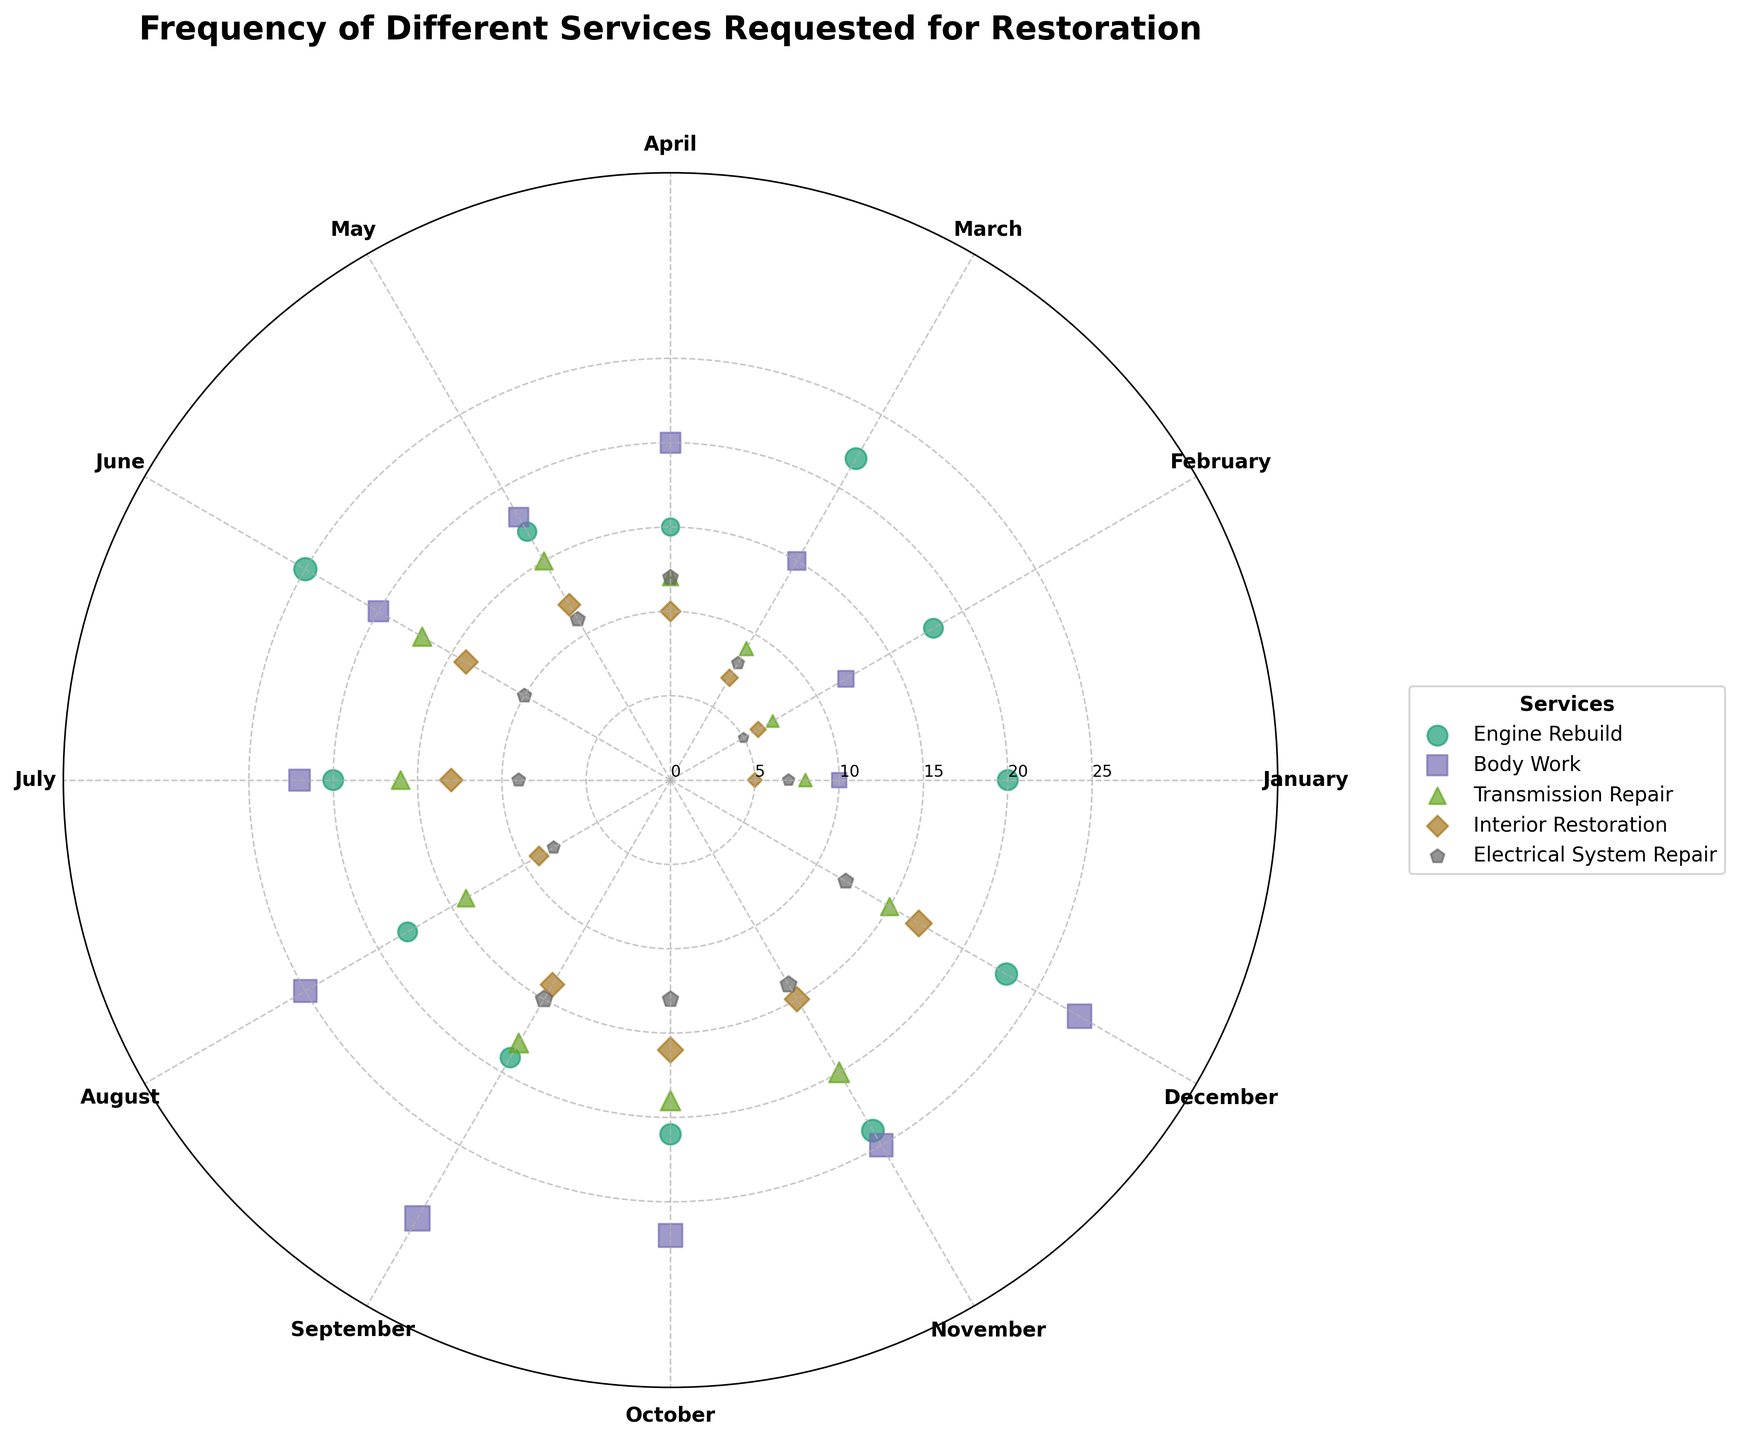What is the title of the chart? The title of the chart appears at the top and reads "Frequency of Different Services Requested for Restoration"
Answer: Frequency of Different Services Requested for Restoration Which service has the highest number of requests in September? A visual inspection of the data points corresponding to September shows that Body Work has the highest number of requests, as indicated by the largest marker in that month
Answer: Body Work How many requests for Engine Rebuild were made in June? Locate the position corresponding to the month of June for the Engine Rebuild data points and count the requests indicated by the size of the marker; it shows 25 requests
Answer: 25 Which month had the least number of requests for Transmission Repair? By comparing the markers for Transmission Repair, it's evident that February has the smallest marker indicating 7 requests, which is the least among the months
Answer: February Compare the number of requests for Body Work between July and November. Which month had more requests, and by how many? In July, the number of requests for Body Work is 22, while in November, it is 25; the difference is 3 more requests in November
Answer: November, 3 more requests What is the average number of requests for Electrical System Repair in the first quarter (January to March)? Sum the requests for January, February, and March, which are 7, 5, and 8 respectively, making a total of 20; then divide by 3, giving an average of 6.67
Answer: 6.67 Identify the number of requests for Interior Restoration in October. How does it compare to Electrical System Repair in the same month? October has 16 requests for Interior Restoration and 13 for Electrical System Repair; Interior Restoration has 3 more requests
Answer: Interior Restoration has 3 more requests What trend do you observe for Engine Rebuild requests over the year? By observing the polar scatter chart, we see that Engine Rebuild requests fluctuate throughout the year but peak around June and November
Answer: Fluctuating with peaks in June and November Which service experiences the highest overall variation in requests throughout the year? Body Work shows a wide range of variability with the lowest in February at 12 and highest in September at 30, indicating significant variation
Answer: Body Work 